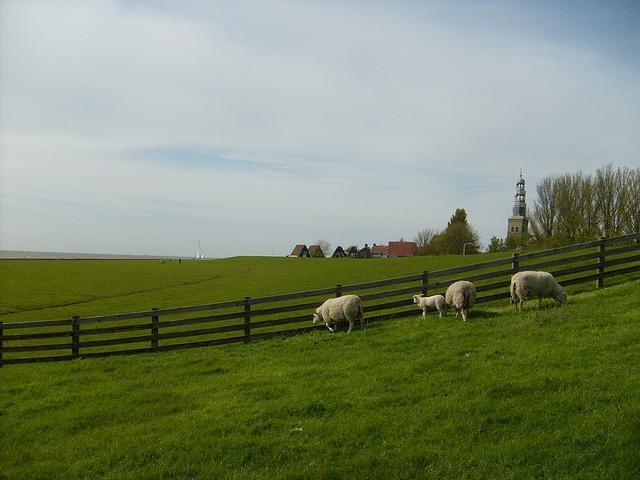How many sheep are there?
Give a very brief answer. 4. How many black sheep?
Give a very brief answer. 0. 